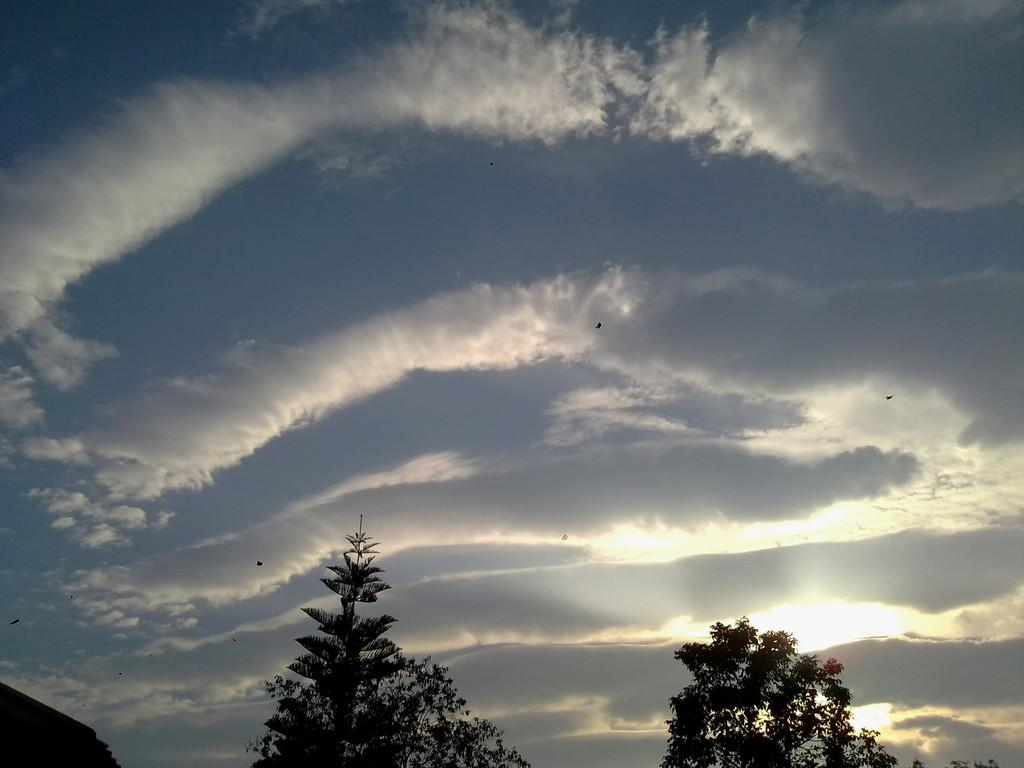What type of vegetation can be seen in the image? There are trees in the image. What part of the natural environment is visible in the image? The sky is visible in the background of the image. Can you describe the object on the left side of the image? Unfortunately, the facts provided do not give enough information to describe the object on the left side of the image. Can you tell me how the owner pets the tree in the image? There is no owner or petting action present in the image; it features trees and a visible sky. 